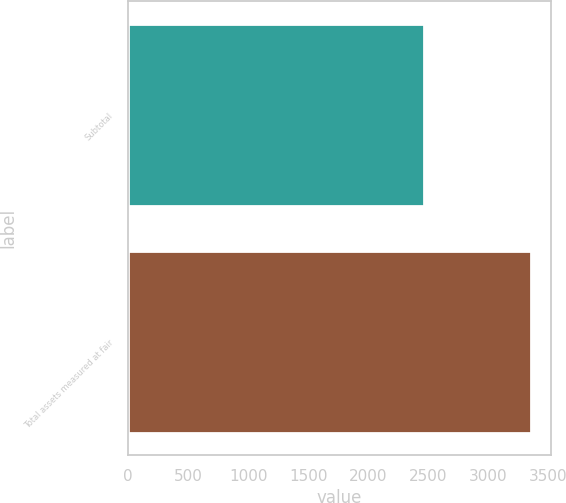Convert chart to OTSL. <chart><loc_0><loc_0><loc_500><loc_500><bar_chart><fcel>Subtotal<fcel>Total assets measured at fair<nl><fcel>2466.6<fcel>3353.4<nl></chart> 